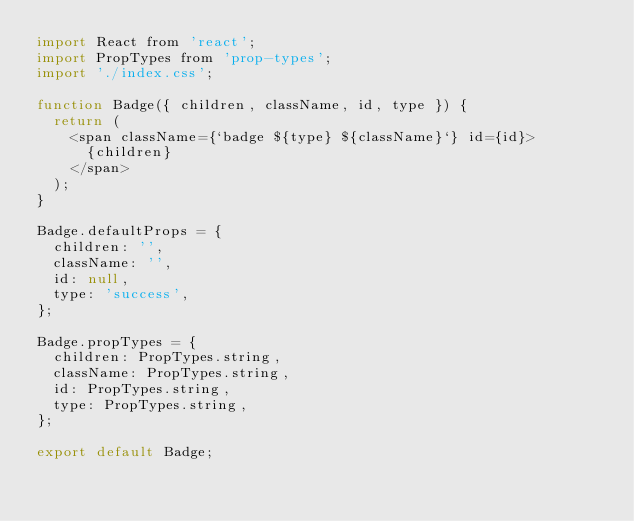Convert code to text. <code><loc_0><loc_0><loc_500><loc_500><_JavaScript_>import React from 'react';
import PropTypes from 'prop-types';
import './index.css';

function Badge({ children, className, id, type }) {
  return (
    <span className={`badge ${type} ${className}`} id={id}>
      {children}
    </span>
  );
}

Badge.defaultProps = {
  children: '',
  className: '',
  id: null,
  type: 'success',
};

Badge.propTypes = {
  children: PropTypes.string,
  className: PropTypes.string,
  id: PropTypes.string,
  type: PropTypes.string,
};

export default Badge;
</code> 